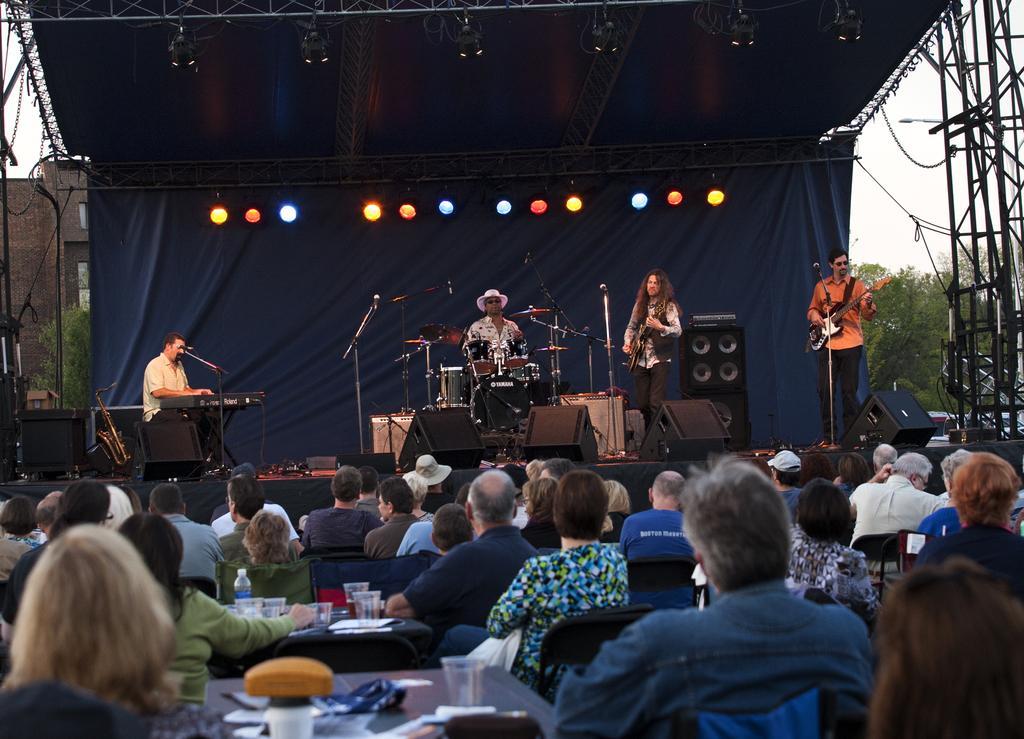Could you give a brief overview of what you see in this image? a rock band is performing on a stage while others are sitting and watching. 